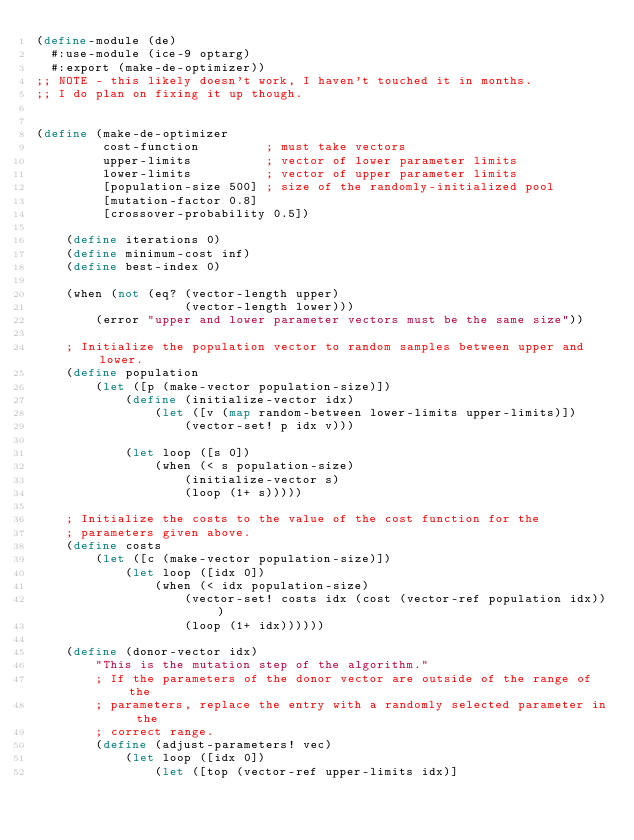<code> <loc_0><loc_0><loc_500><loc_500><_Scheme_>(define-module (de)
  #:use-module (ice-9 optarg)
  #:export (make-de-optimizer))
;; NOTE - this likely doesn't work, I haven't touched it in months.
;; I do plan on fixing it up though.
 

(define (make-de-optimizer
         cost-function         ; must take vectors
         upper-limits          ; vector of lower parameter limits
         lower-limits          ; vector of upper parameter limits
         [population-size 500] ; size of the randomly-initialized pool
         [mutation-factor 0.8]
         [crossover-probability 0.5])
  
    (define iterations 0)
    (define minimum-cost inf)
    (define best-index 0)

    (when (not (eq? (vector-length upper)
                    (vector-length lower)))
        (error "upper and lower parameter vectors must be the same size"))

    ; Initialize the population vector to random samples between upper and lower.
    (define population
        (let ([p (make-vector population-size)])
            (define (initialize-vector idx)
                (let ([v (map random-between lower-limits upper-limits)])
                    (vector-set! p idx v)))
  
            (let loop ([s 0])
                (when (< s population-size)
                    (initialize-vector s)
                    (loop (1+ s)))))

    ; Initialize the costs to the value of the cost function for the
    ; parameters given above.
    (define costs
        (let ([c (make-vector population-size)])
            (let loop ([idx 0])
                (when (< idx population-size)
                    (vector-set! costs idx (cost (vector-ref population idx)))
                    (loop (1+ idx))))))

    (define (donor-vector idx)
        "This is the mutation step of the algorithm."
        ; If the parameters of the donor vector are outside of the range of the
        ; parameters, replace the entry with a randomly selected parameter in the
        ; correct range.
        (define (adjust-parameters! vec)
            (let loop ([idx 0])
                (let ([top (vector-ref upper-limits idx)]</code> 